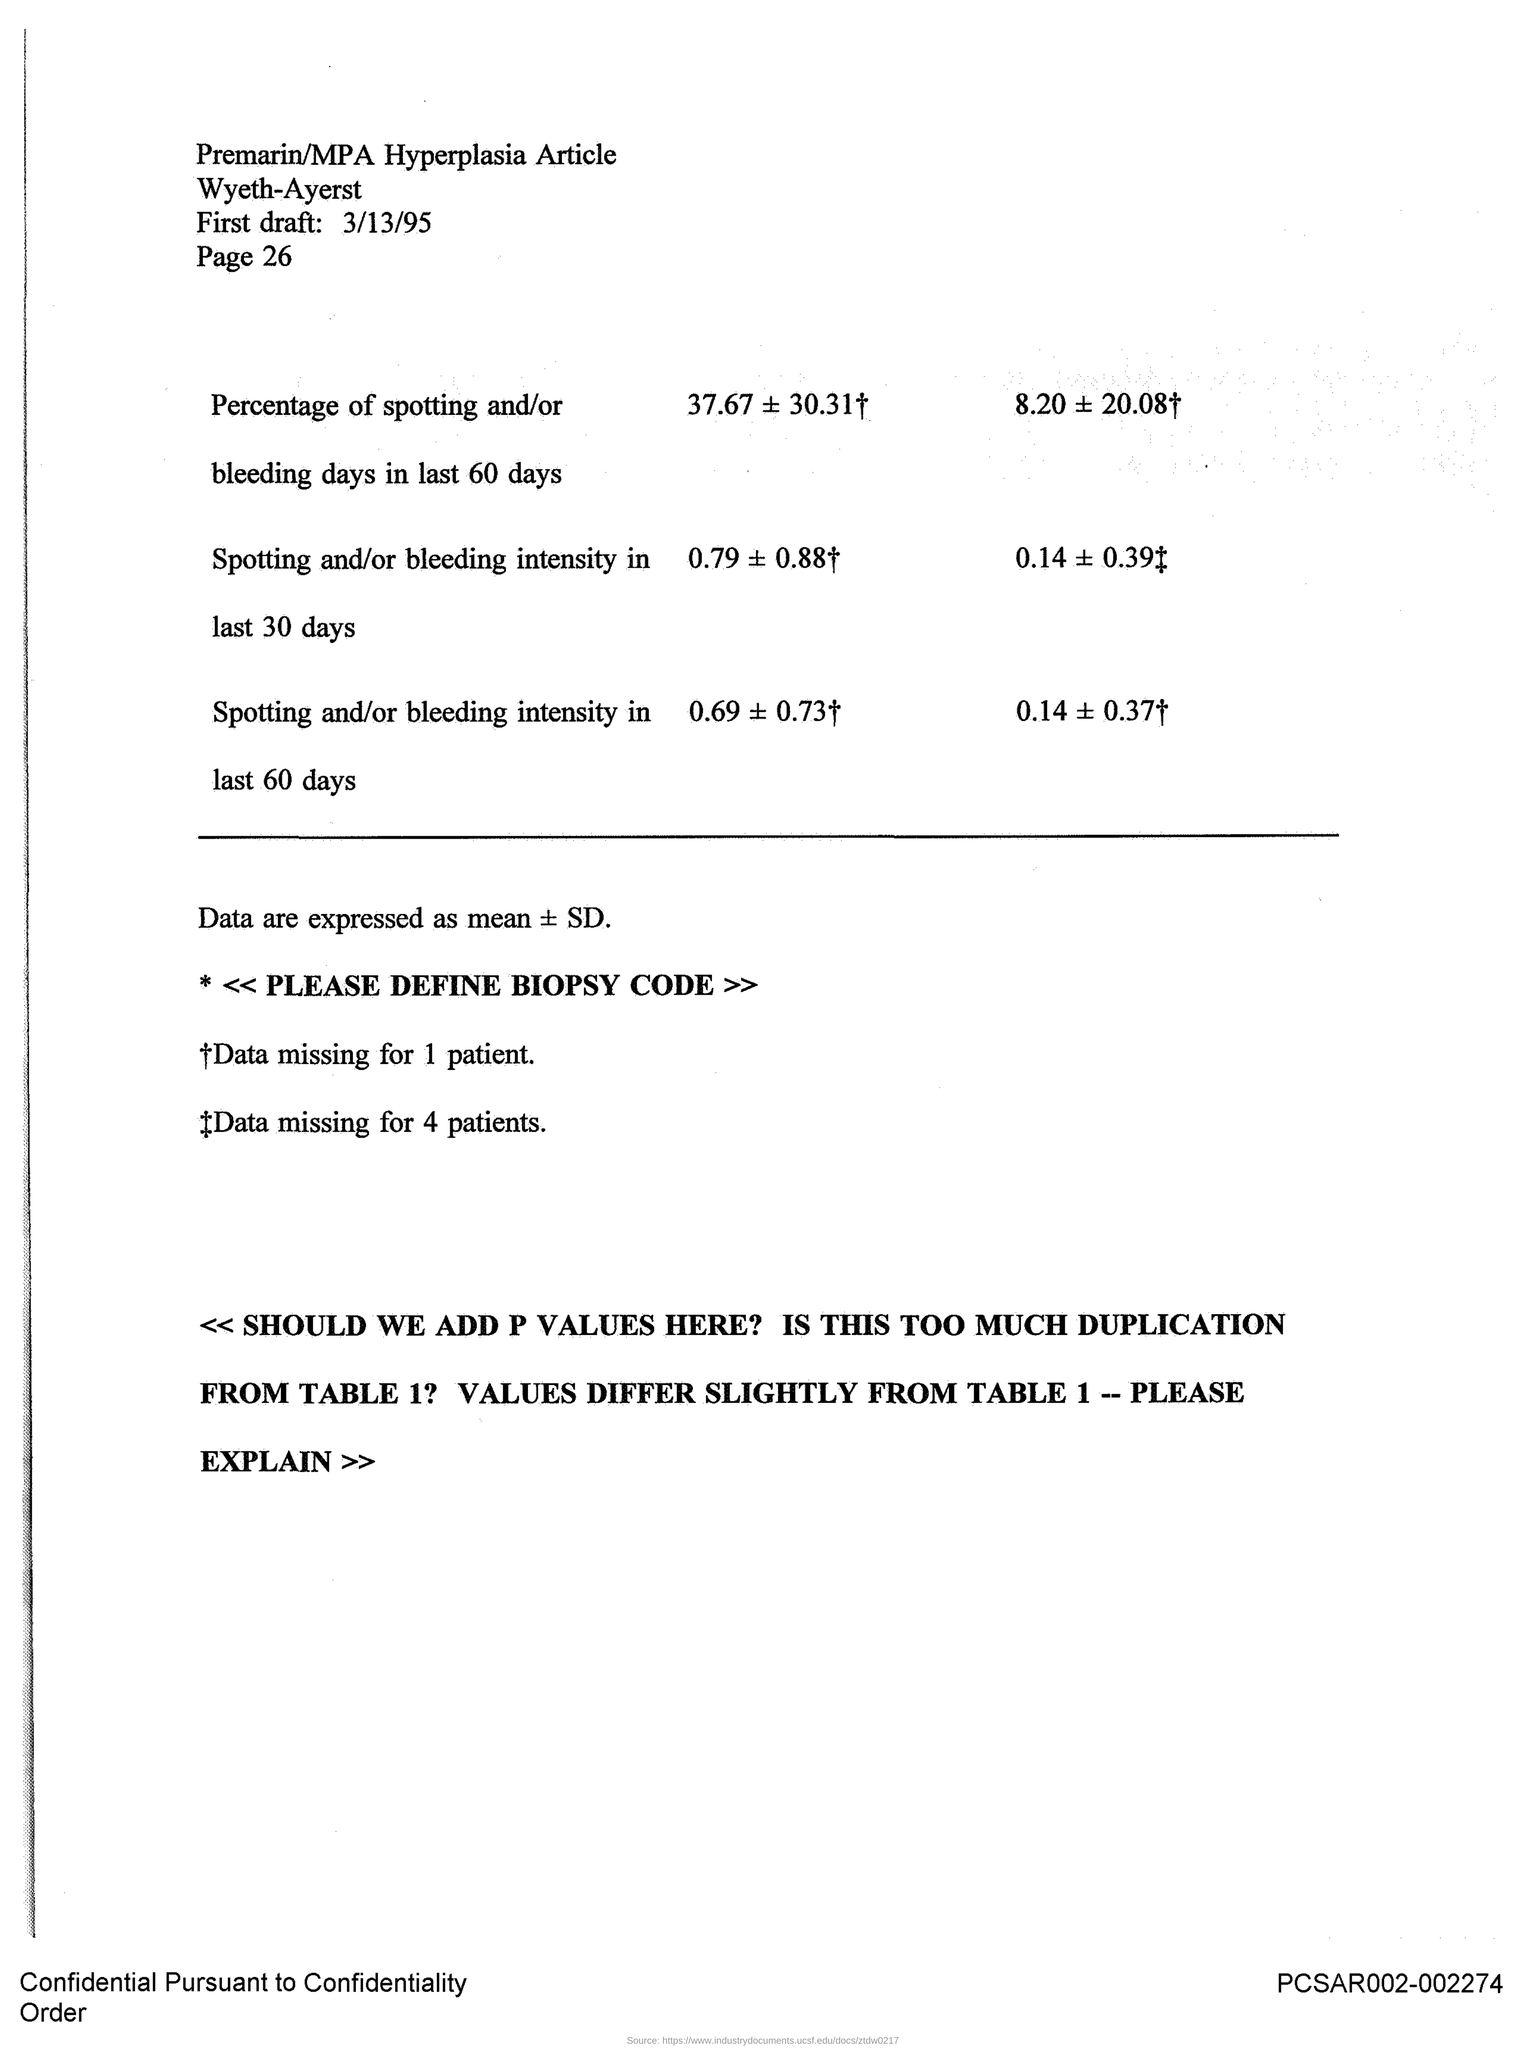Identify some key points in this picture. The page is page 26. The first draft is scheduled for March 13, 1995. 